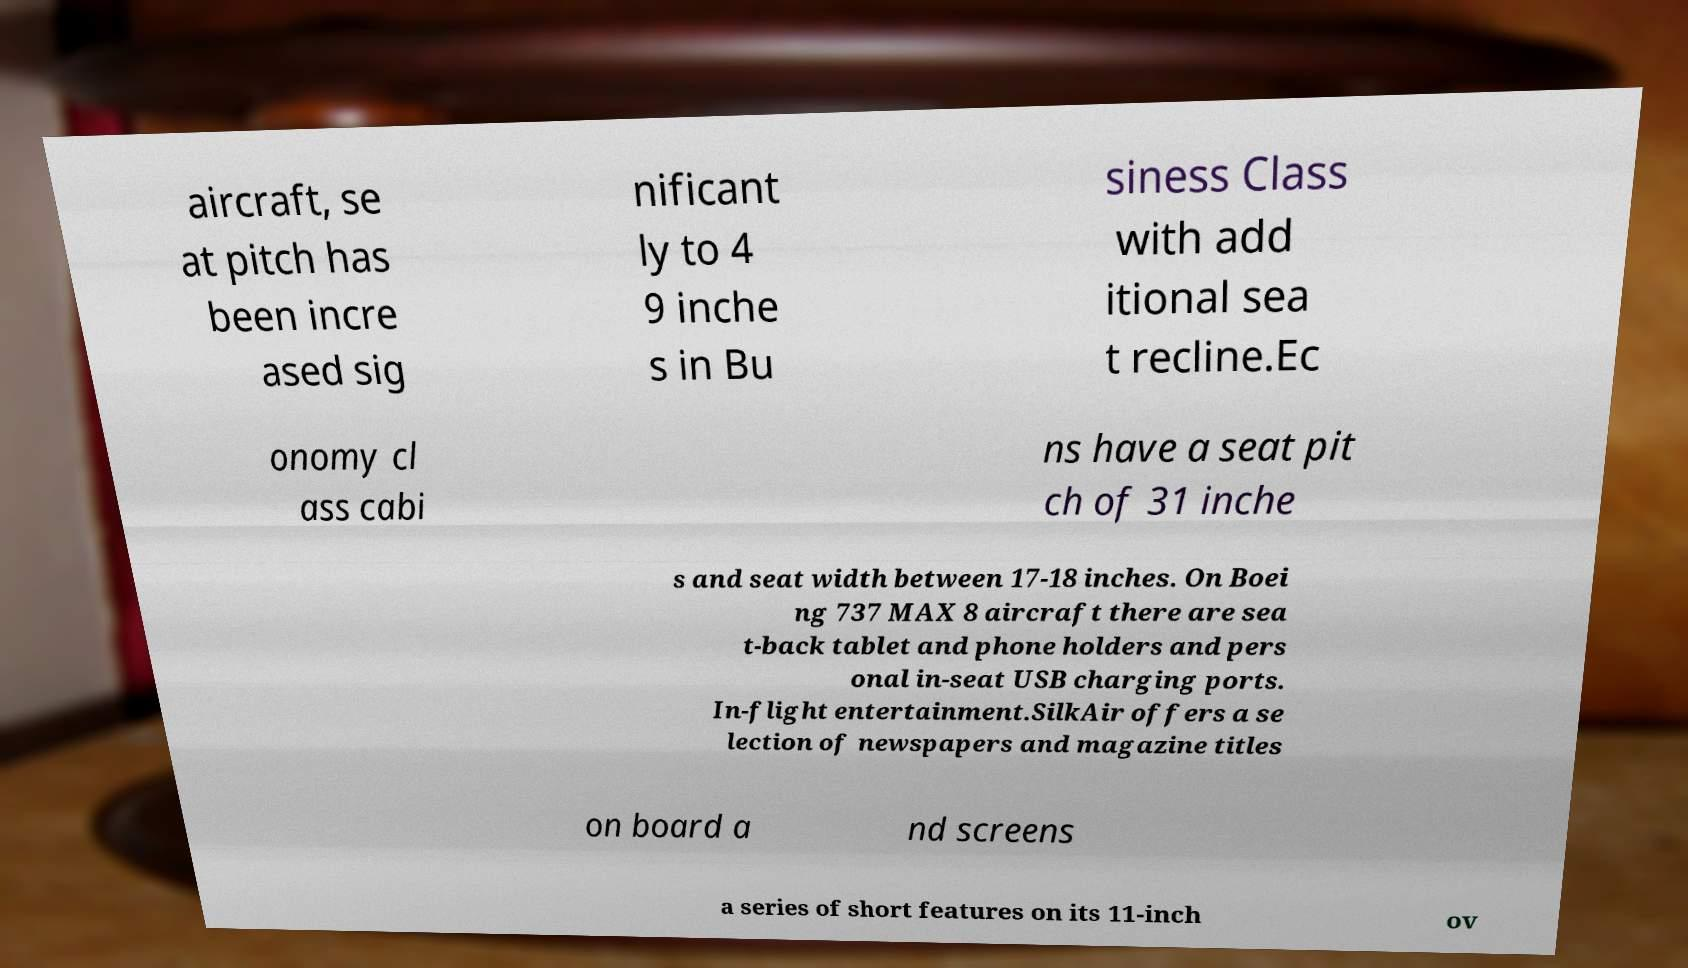Could you assist in decoding the text presented in this image and type it out clearly? aircraft, se at pitch has been incre ased sig nificant ly to 4 9 inche s in Bu siness Class with add itional sea t recline.Ec onomy cl ass cabi ns have a seat pit ch of 31 inche s and seat width between 17-18 inches. On Boei ng 737 MAX 8 aircraft there are sea t-back tablet and phone holders and pers onal in-seat USB charging ports. In-flight entertainment.SilkAir offers a se lection of newspapers and magazine titles on board a nd screens a series of short features on its 11-inch ov 